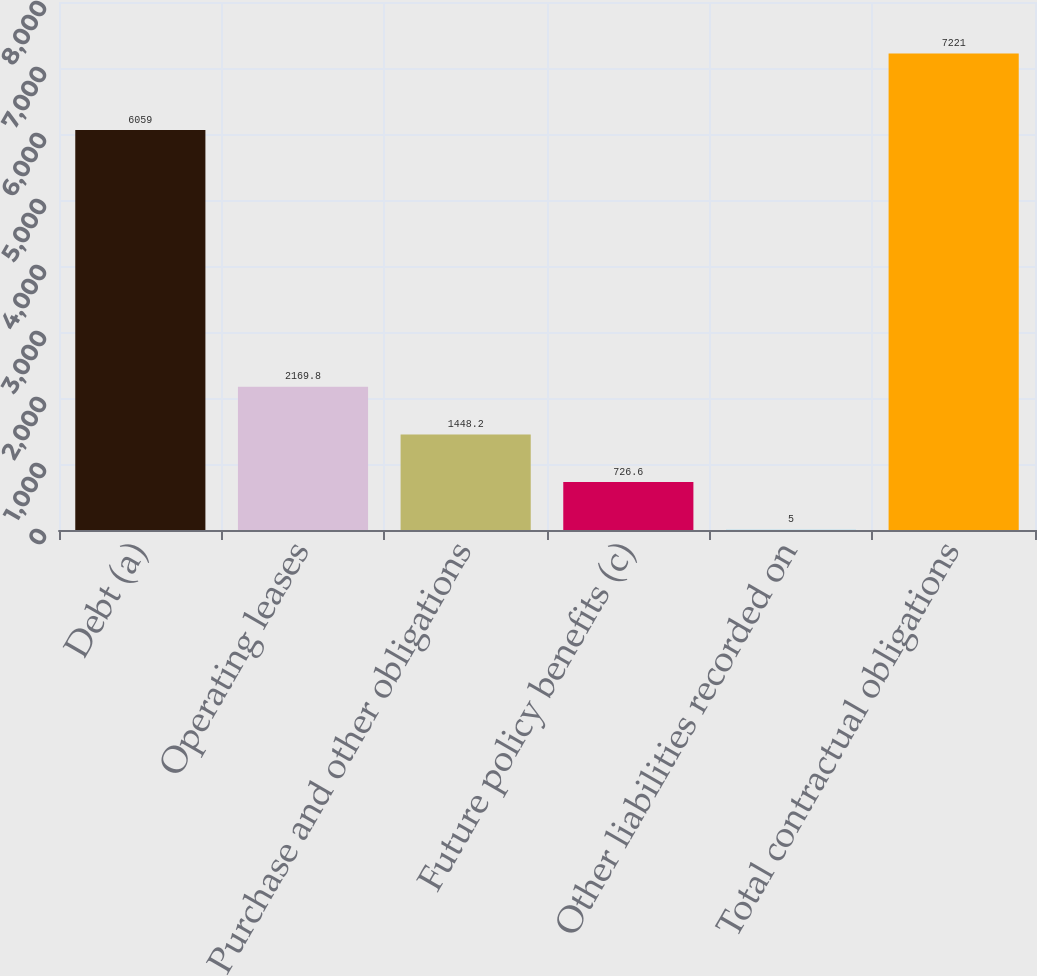Convert chart. <chart><loc_0><loc_0><loc_500><loc_500><bar_chart><fcel>Debt (a)<fcel>Operating leases<fcel>Purchase and other obligations<fcel>Future policy benefits (c)<fcel>Other liabilities recorded on<fcel>Total contractual obligations<nl><fcel>6059<fcel>2169.8<fcel>1448.2<fcel>726.6<fcel>5<fcel>7221<nl></chart> 